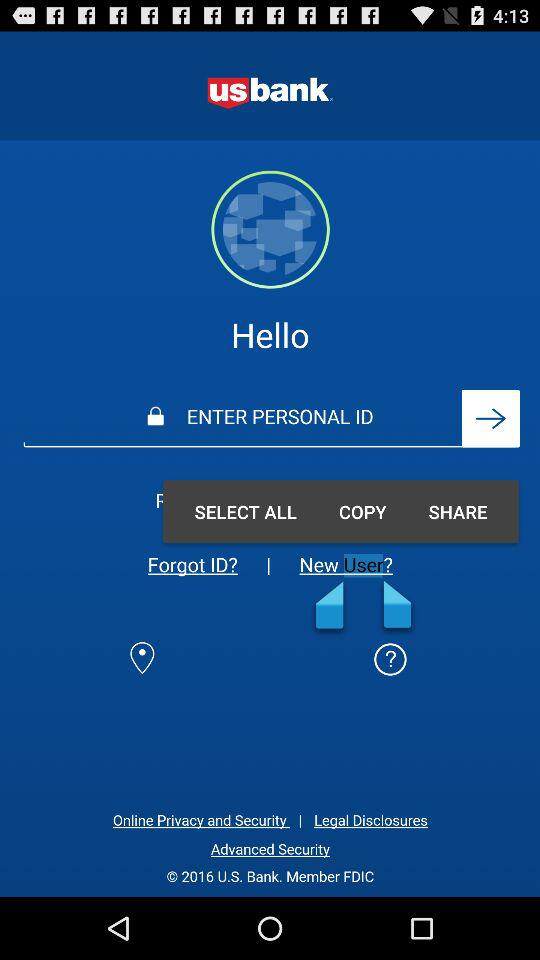How many text inputs are on the screen?
Answer the question using a single word or phrase. 1 